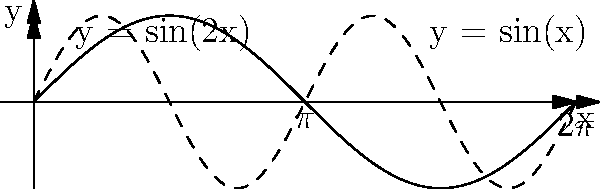In designing a new ambient soundscape for your meditation app, you're considering using intersecting sine waves to create a unique audio pattern. The waves are represented by the functions $y = \sin(x)$ and $y = \sin(2x)$ on the interval $[0, 2\pi]$. Calculate the area of the region bounded by these two curves where $\sin(2x) \geq \sin(x)$. This area could represent the intensity of the overlapping sounds in your audio design. To solve this problem, we'll follow these steps:

1) First, we need to find the points of intersection of the two curves. We can do this by setting the equations equal to each other:
   $\sin(x) = \sin(2x)$

2) This equation is satisfied when $x = 0$, $\pi/2$, $\pi$, and $3\pi/2$ in the interval $[0, 2\pi]$.

3) Now, we need to determine where $\sin(2x) \geq \sin(x)$. This occurs in the intervals $[0, \pi/2]$ and $[\pi, 3\pi/2]$.

4) The area we're looking for is the integral of the difference between the two functions over these intervals:

   $$A = \int_0^{\pi/2} [\sin(2x) - \sin(x)] dx + \int_{\pi}^{3\pi/2} [\sin(2x) - \sin(x)] dx$$

5) Let's solve each integral:
   
   For the first integral:
   $$\int_0^{\pi/2} [\sin(2x) - \sin(x)] dx = [-\frac{1}{2}\cos(2x) + \cos(x)]_0^{\pi/2} = (-0 + 0) - (-\frac{1}{2} + 1) = \frac{1}{2}$$

   For the second integral:
   $$\int_{\pi}^{3\pi/2} [\sin(2x) - \sin(x)] dx = [-\frac{1}{2}\cos(2x) + \cos(x)]_{\pi}^{3\pi/2} = (0 - 0) - (\frac{1}{2} - 1) = \frac{1}{2}$$

6) The total area is the sum of these two integrals:
   $$A = \frac{1}{2} + \frac{1}{2} = 1$$

Therefore, the area of the region where $\sin(2x) \geq \sin(x)$ is 1 square unit.
Answer: 1 square unit 